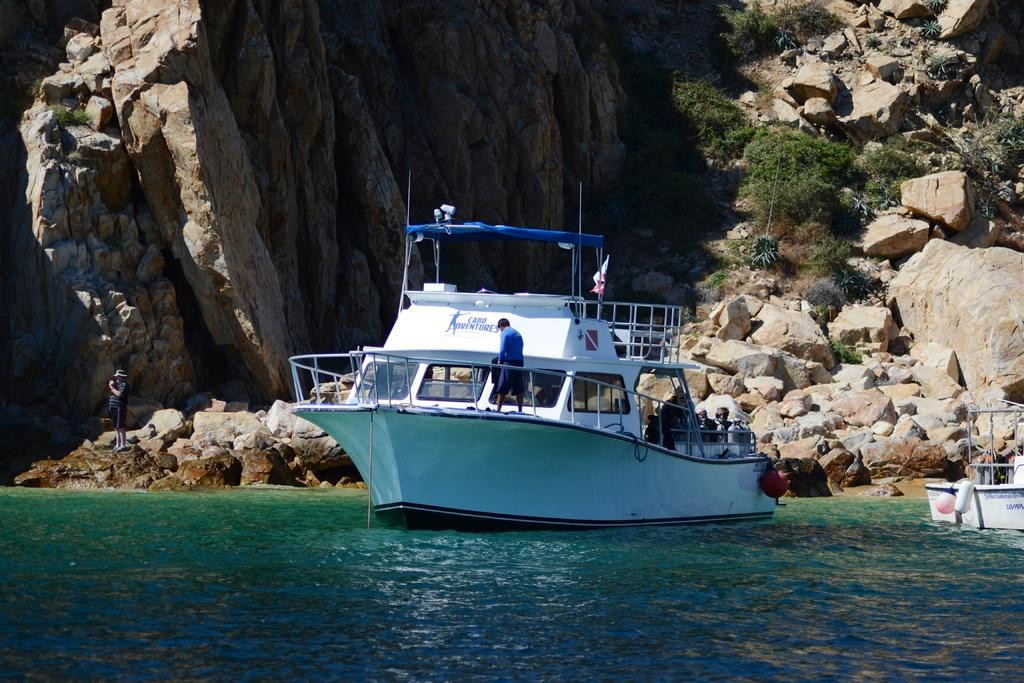<image>
Present a compact description of the photo's key features. White ship in the waters and the words "Cabo Adventures" on the back. 